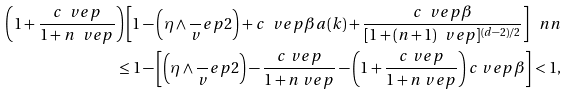<formula> <loc_0><loc_0><loc_500><loc_500>\left ( 1 + \frac { c \ v e p } { 1 + n \ v e p } \right ) \left [ 1 - \left ( \eta \wedge \frac { \ } { v } e p 2 \right ) + c \ v e p \beta a ( k ) + \frac { c \ v e p \beta } { [ 1 + ( n + 1 ) \ v e p ] ^ { ( d - 2 ) / 2 } } \right ] \ n n \\ \quad \leq 1 - \left [ \left ( \eta \wedge \frac { \ } { v } e p 2 \right ) - \frac { c \ v e p } { 1 + n \ v e p } - \left ( 1 + \frac { c \ v e p } { 1 + n \ v e p } \right ) c \ v e p \beta \right ] < 1 ,</formula> 